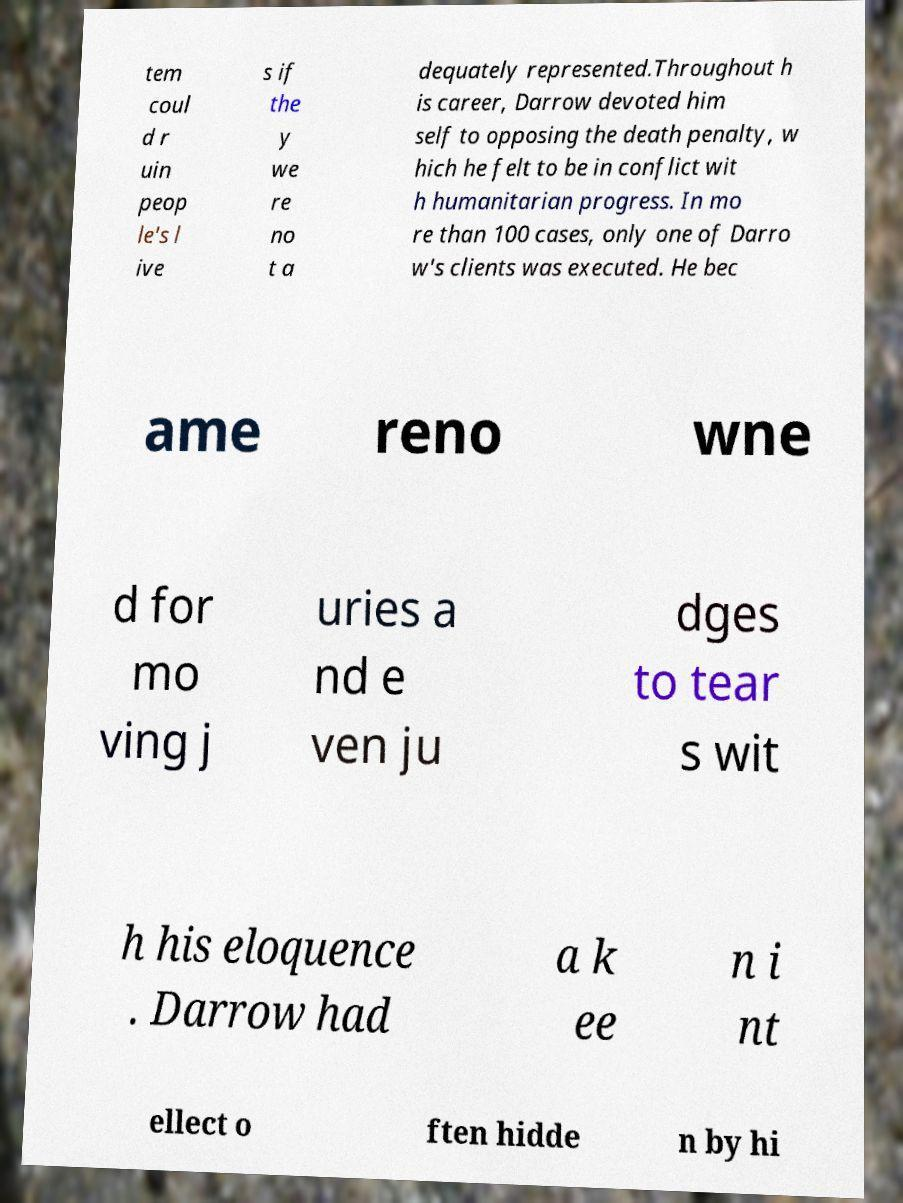What messages or text are displayed in this image? I need them in a readable, typed format. tem coul d r uin peop le's l ive s if the y we re no t a dequately represented.Throughout h is career, Darrow devoted him self to opposing the death penalty, w hich he felt to be in conflict wit h humanitarian progress. In mo re than 100 cases, only one of Darro w's clients was executed. He bec ame reno wne d for mo ving j uries a nd e ven ju dges to tear s wit h his eloquence . Darrow had a k ee n i nt ellect o ften hidde n by hi 